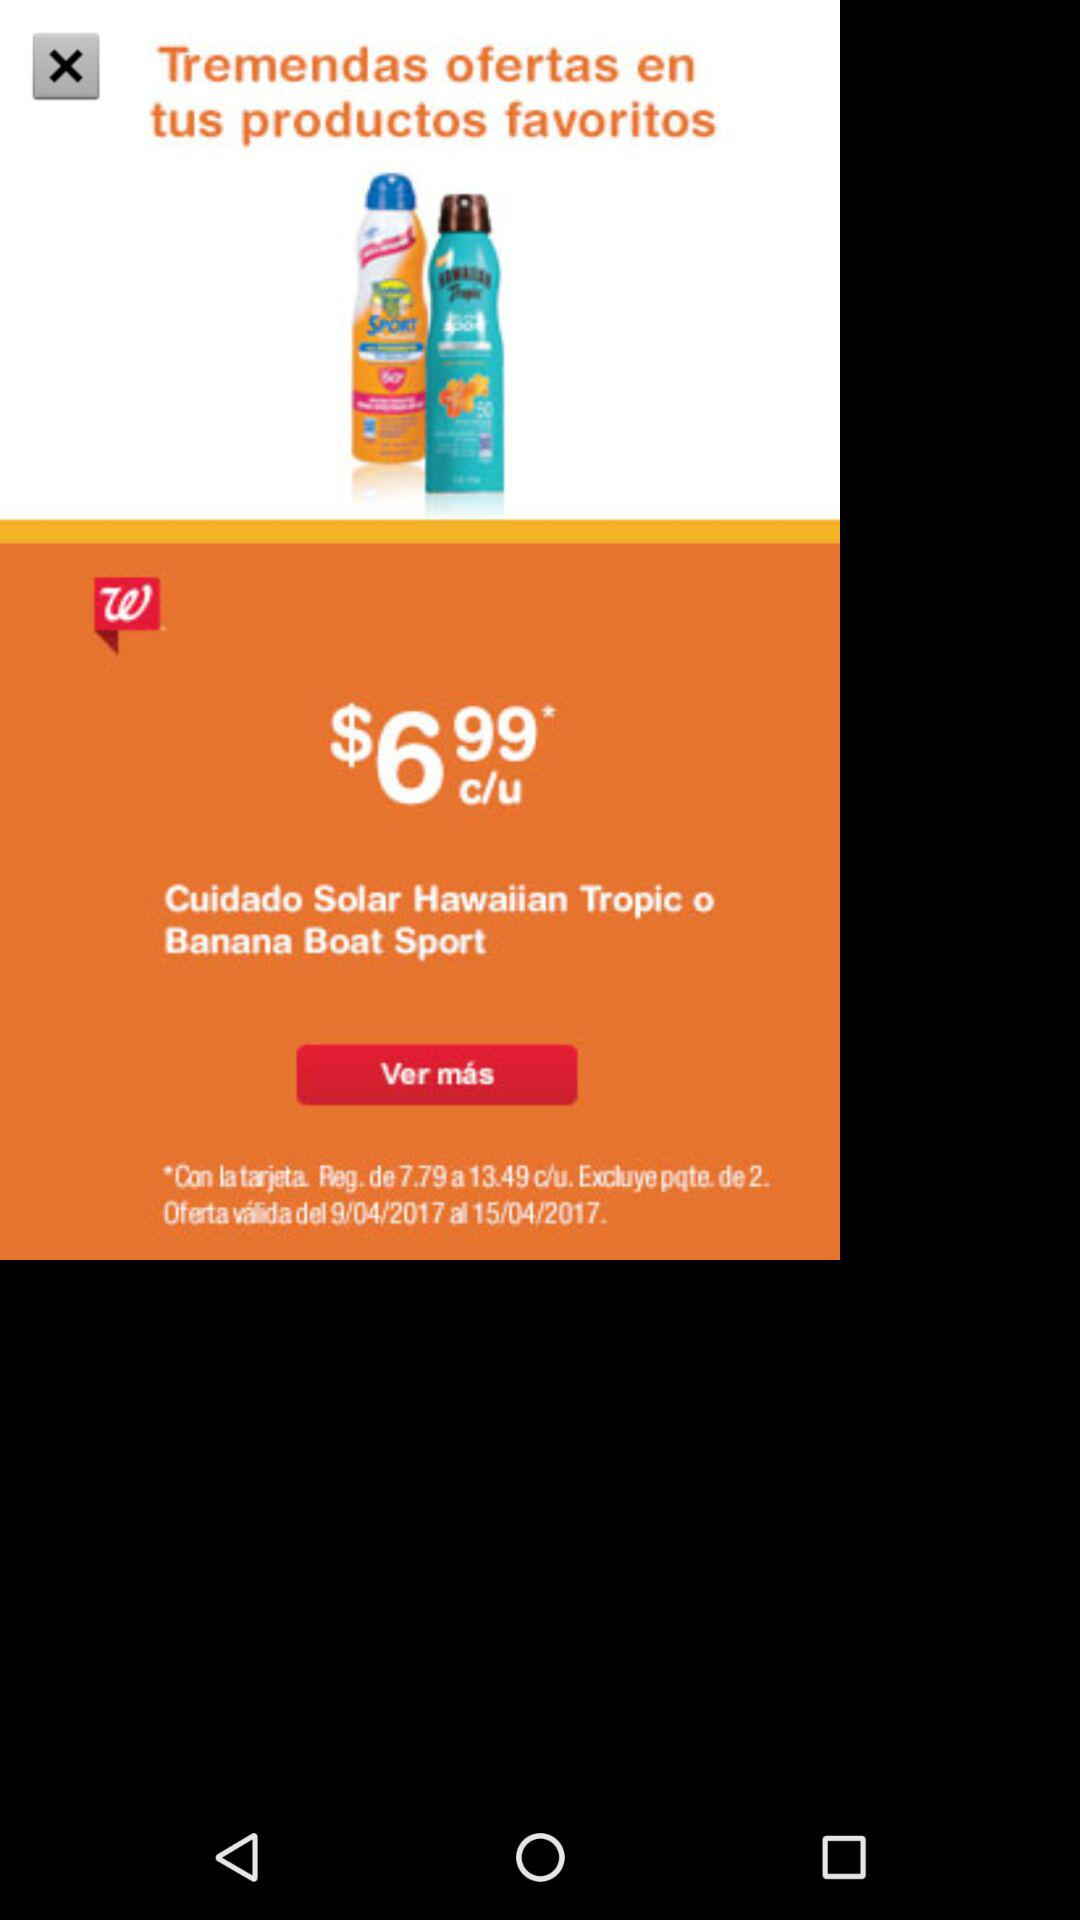How much is the offer price for each bottle of sunscreen?
Answer the question using a single word or phrase. $6.99 